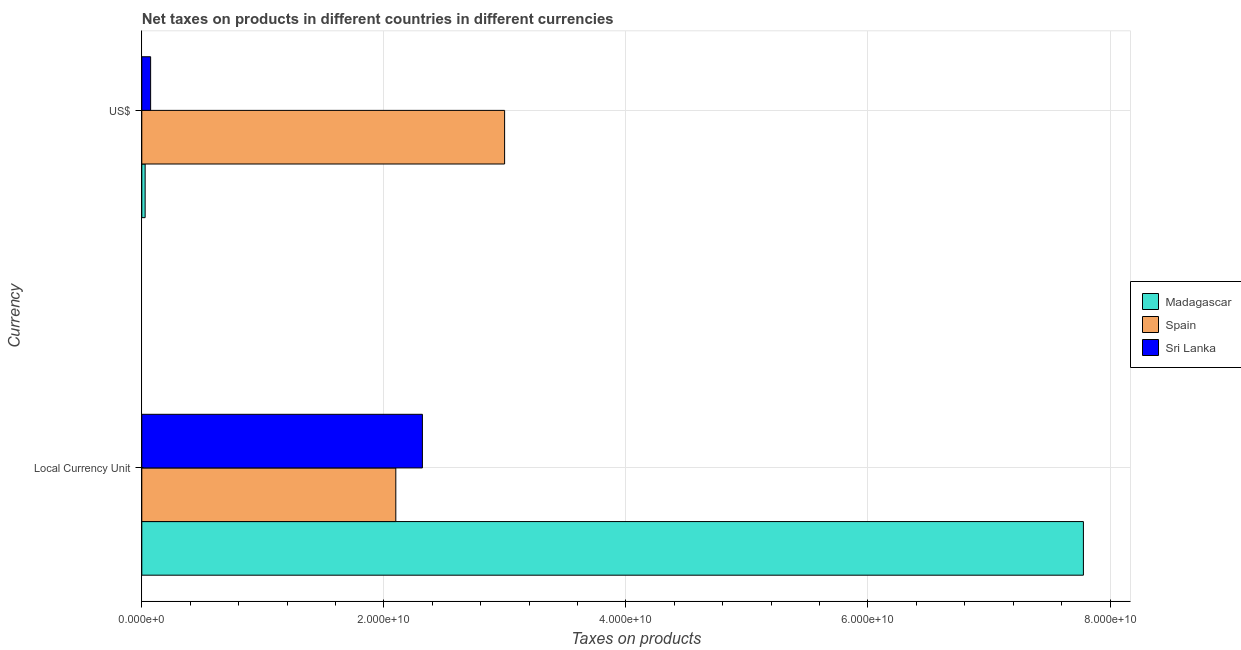How many different coloured bars are there?
Give a very brief answer. 3. How many groups of bars are there?
Provide a succinct answer. 2. Are the number of bars per tick equal to the number of legend labels?
Provide a short and direct response. Yes. Are the number of bars on each tick of the Y-axis equal?
Offer a very short reply. Yes. How many bars are there on the 2nd tick from the top?
Keep it short and to the point. 3. How many bars are there on the 1st tick from the bottom?
Offer a terse response. 3. What is the label of the 1st group of bars from the top?
Keep it short and to the point. US$. What is the net taxes in us$ in Spain?
Keep it short and to the point. 3.00e+1. Across all countries, what is the maximum net taxes in us$?
Keep it short and to the point. 3.00e+1. Across all countries, what is the minimum net taxes in us$?
Ensure brevity in your answer.  2.76e+08. In which country was the net taxes in us$ maximum?
Your response must be concise. Spain. In which country was the net taxes in us$ minimum?
Provide a short and direct response. Madagascar. What is the total net taxes in us$ in the graph?
Your answer should be very brief. 3.10e+1. What is the difference between the net taxes in us$ in Sri Lanka and that in Spain?
Your answer should be compact. -2.92e+1. What is the difference between the net taxes in us$ in Spain and the net taxes in constant 2005 us$ in Madagascar?
Keep it short and to the point. -4.78e+1. What is the average net taxes in constant 2005 us$ per country?
Provide a short and direct response. 4.07e+1. What is the difference between the net taxes in constant 2005 us$ and net taxes in us$ in Spain?
Offer a very short reply. -8.99e+09. In how many countries, is the net taxes in us$ greater than 8000000000 units?
Provide a short and direct response. 1. What is the ratio of the net taxes in constant 2005 us$ in Sri Lanka to that in Madagascar?
Provide a short and direct response. 0.3. Is the net taxes in us$ in Madagascar less than that in Sri Lanka?
Your response must be concise. Yes. In how many countries, is the net taxes in constant 2005 us$ greater than the average net taxes in constant 2005 us$ taken over all countries?
Your response must be concise. 1. What does the 3rd bar from the top in Local Currency Unit represents?
Provide a short and direct response. Madagascar. What does the 2nd bar from the bottom in US$ represents?
Your answer should be very brief. Spain. Are all the bars in the graph horizontal?
Make the answer very short. Yes. Where does the legend appear in the graph?
Your answer should be very brief. Center right. How many legend labels are there?
Provide a succinct answer. 3. What is the title of the graph?
Offer a terse response. Net taxes on products in different countries in different currencies. Does "Puerto Rico" appear as one of the legend labels in the graph?
Offer a very short reply. No. What is the label or title of the X-axis?
Your response must be concise. Taxes on products. What is the label or title of the Y-axis?
Offer a terse response. Currency. What is the Taxes on products in Madagascar in Local Currency Unit?
Provide a short and direct response. 7.78e+1. What is the Taxes on products of Spain in Local Currency Unit?
Make the answer very short. 2.10e+1. What is the Taxes on products of Sri Lanka in Local Currency Unit?
Offer a terse response. 2.32e+1. What is the Taxes on products of Madagascar in US$?
Offer a very short reply. 2.76e+08. What is the Taxes on products of Spain in US$?
Your response must be concise. 3.00e+1. What is the Taxes on products of Sri Lanka in US$?
Offer a very short reply. 7.29e+08. Across all Currency, what is the maximum Taxes on products in Madagascar?
Make the answer very short. 7.78e+1. Across all Currency, what is the maximum Taxes on products of Spain?
Keep it short and to the point. 3.00e+1. Across all Currency, what is the maximum Taxes on products in Sri Lanka?
Your answer should be very brief. 2.32e+1. Across all Currency, what is the minimum Taxes on products in Madagascar?
Your answer should be very brief. 2.76e+08. Across all Currency, what is the minimum Taxes on products of Spain?
Your answer should be compact. 2.10e+1. Across all Currency, what is the minimum Taxes on products of Sri Lanka?
Provide a short and direct response. 7.29e+08. What is the total Taxes on products of Madagascar in the graph?
Offer a terse response. 7.81e+1. What is the total Taxes on products of Spain in the graph?
Provide a succinct answer. 5.10e+1. What is the total Taxes on products in Sri Lanka in the graph?
Provide a succinct answer. 2.39e+1. What is the difference between the Taxes on products of Madagascar in Local Currency Unit and that in US$?
Your answer should be very brief. 7.75e+1. What is the difference between the Taxes on products of Spain in Local Currency Unit and that in US$?
Give a very brief answer. -8.99e+09. What is the difference between the Taxes on products in Sri Lanka in Local Currency Unit and that in US$?
Offer a very short reply. 2.25e+1. What is the difference between the Taxes on products of Madagascar in Local Currency Unit and the Taxes on products of Spain in US$?
Ensure brevity in your answer.  4.78e+1. What is the difference between the Taxes on products in Madagascar in Local Currency Unit and the Taxes on products in Sri Lanka in US$?
Ensure brevity in your answer.  7.71e+1. What is the difference between the Taxes on products of Spain in Local Currency Unit and the Taxes on products of Sri Lanka in US$?
Ensure brevity in your answer.  2.03e+1. What is the average Taxes on products of Madagascar per Currency?
Make the answer very short. 3.90e+1. What is the average Taxes on products in Spain per Currency?
Make the answer very short. 2.55e+1. What is the average Taxes on products in Sri Lanka per Currency?
Your answer should be compact. 1.20e+1. What is the difference between the Taxes on products in Madagascar and Taxes on products in Spain in Local Currency Unit?
Make the answer very short. 5.68e+1. What is the difference between the Taxes on products of Madagascar and Taxes on products of Sri Lanka in Local Currency Unit?
Provide a short and direct response. 5.46e+1. What is the difference between the Taxes on products in Spain and Taxes on products in Sri Lanka in Local Currency Unit?
Offer a terse response. -2.20e+09. What is the difference between the Taxes on products of Madagascar and Taxes on products of Spain in US$?
Offer a terse response. -2.97e+1. What is the difference between the Taxes on products in Madagascar and Taxes on products in Sri Lanka in US$?
Provide a succinct answer. -4.52e+08. What is the difference between the Taxes on products in Spain and Taxes on products in Sri Lanka in US$?
Your response must be concise. 2.92e+1. What is the ratio of the Taxes on products of Madagascar in Local Currency Unit to that in US$?
Make the answer very short. 281.42. What is the ratio of the Taxes on products of Spain in Local Currency Unit to that in US$?
Your answer should be very brief. 0.7. What is the ratio of the Taxes on products of Sri Lanka in Local Currency Unit to that in US$?
Offer a very short reply. 31.81. What is the difference between the highest and the second highest Taxes on products in Madagascar?
Make the answer very short. 7.75e+1. What is the difference between the highest and the second highest Taxes on products of Spain?
Provide a succinct answer. 8.99e+09. What is the difference between the highest and the second highest Taxes on products in Sri Lanka?
Provide a succinct answer. 2.25e+1. What is the difference between the highest and the lowest Taxes on products in Madagascar?
Make the answer very short. 7.75e+1. What is the difference between the highest and the lowest Taxes on products in Spain?
Provide a succinct answer. 8.99e+09. What is the difference between the highest and the lowest Taxes on products of Sri Lanka?
Provide a succinct answer. 2.25e+1. 